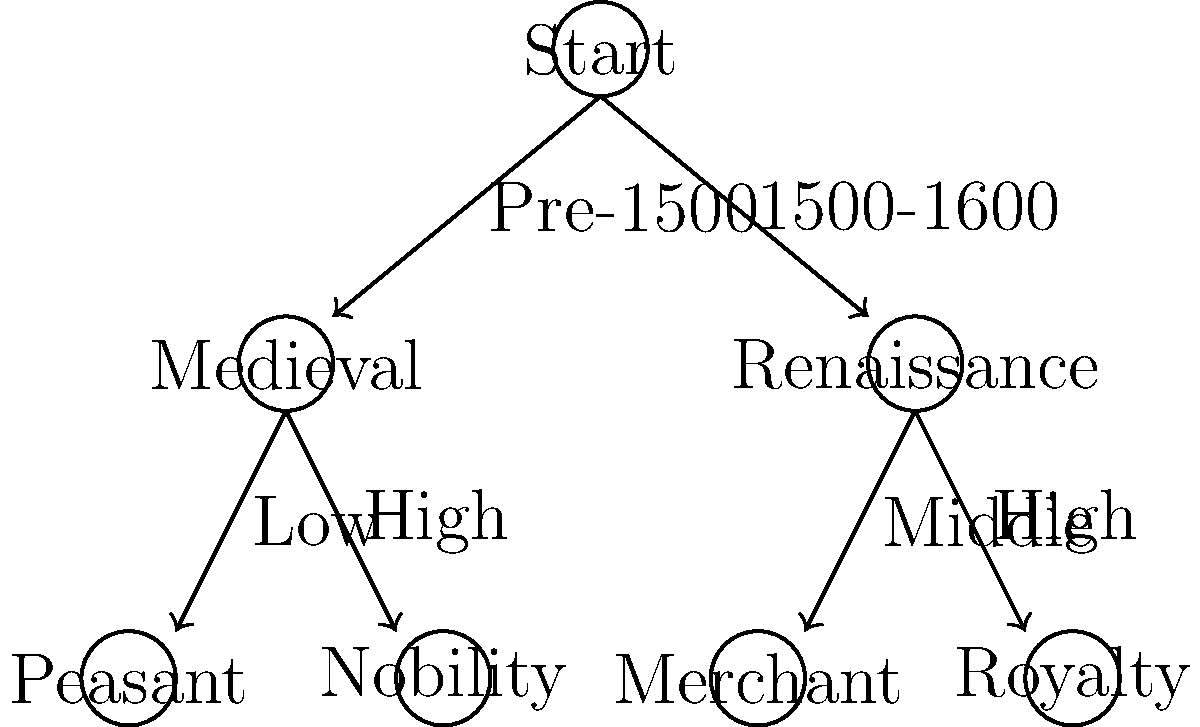In the decision tree for selecting appropriate costumes based on historical period and social status, how many possible paths are there from the "Start" node to a final costume selection? To determine the number of possible paths from the "Start" node to a final costume selection, we need to follow these steps:

1. Identify the starting point: We begin at the "Start" node.

2. Analyze the first level of decisions:
   - There are two options: "Pre-1500" (Medieval) and "1500-1600" (Renaissance)

3. Analyze the second level of decisions:
   - For the Medieval branch:
     - There are two options: "Low" (Peasant) and "High" (Nobility)
   - For the Renaissance branch:
     - There are two options: "Middle" (Merchant) and "High" (Royalty)

4. Count the number of complete paths:
   - Medieval path 1: Start → Medieval → Peasant
   - Medieval path 2: Start → Medieval → Nobility
   - Renaissance path 1: Start → Renaissance → Merchant
   - Renaissance path 2: Start → Renaissance → Royalty

5. Sum up the total number of paths:
   $2 + 2 = 4$ total paths

Therefore, there are 4 possible paths from the "Start" node to a final costume selection in this decision tree.
Answer: 4 